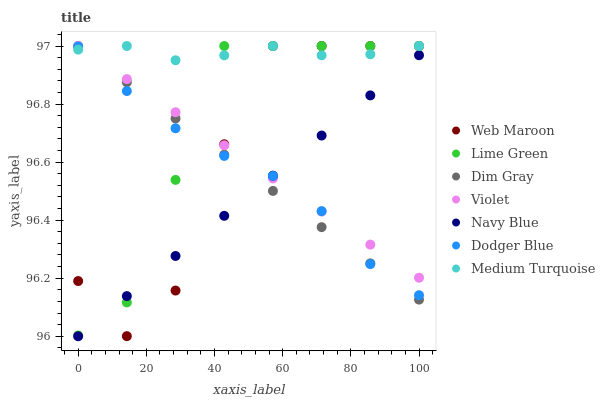Does Navy Blue have the minimum area under the curve?
Answer yes or no. Yes. Does Medium Turquoise have the maximum area under the curve?
Answer yes or no. Yes. Does Web Maroon have the minimum area under the curve?
Answer yes or no. No. Does Web Maroon have the maximum area under the curve?
Answer yes or no. No. Is Navy Blue the smoothest?
Answer yes or no. Yes. Is Web Maroon the roughest?
Answer yes or no. Yes. Is Web Maroon the smoothest?
Answer yes or no. No. Is Navy Blue the roughest?
Answer yes or no. No. Does Navy Blue have the lowest value?
Answer yes or no. Yes. Does Web Maroon have the lowest value?
Answer yes or no. No. Does Lime Green have the highest value?
Answer yes or no. Yes. Does Navy Blue have the highest value?
Answer yes or no. No. Is Navy Blue less than Medium Turquoise?
Answer yes or no. Yes. Is Medium Turquoise greater than Navy Blue?
Answer yes or no. Yes. Does Violet intersect Lime Green?
Answer yes or no. Yes. Is Violet less than Lime Green?
Answer yes or no. No. Is Violet greater than Lime Green?
Answer yes or no. No. Does Navy Blue intersect Medium Turquoise?
Answer yes or no. No. 